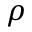Convert formula to latex. <formula><loc_0><loc_0><loc_500><loc_500>\rho</formula> 